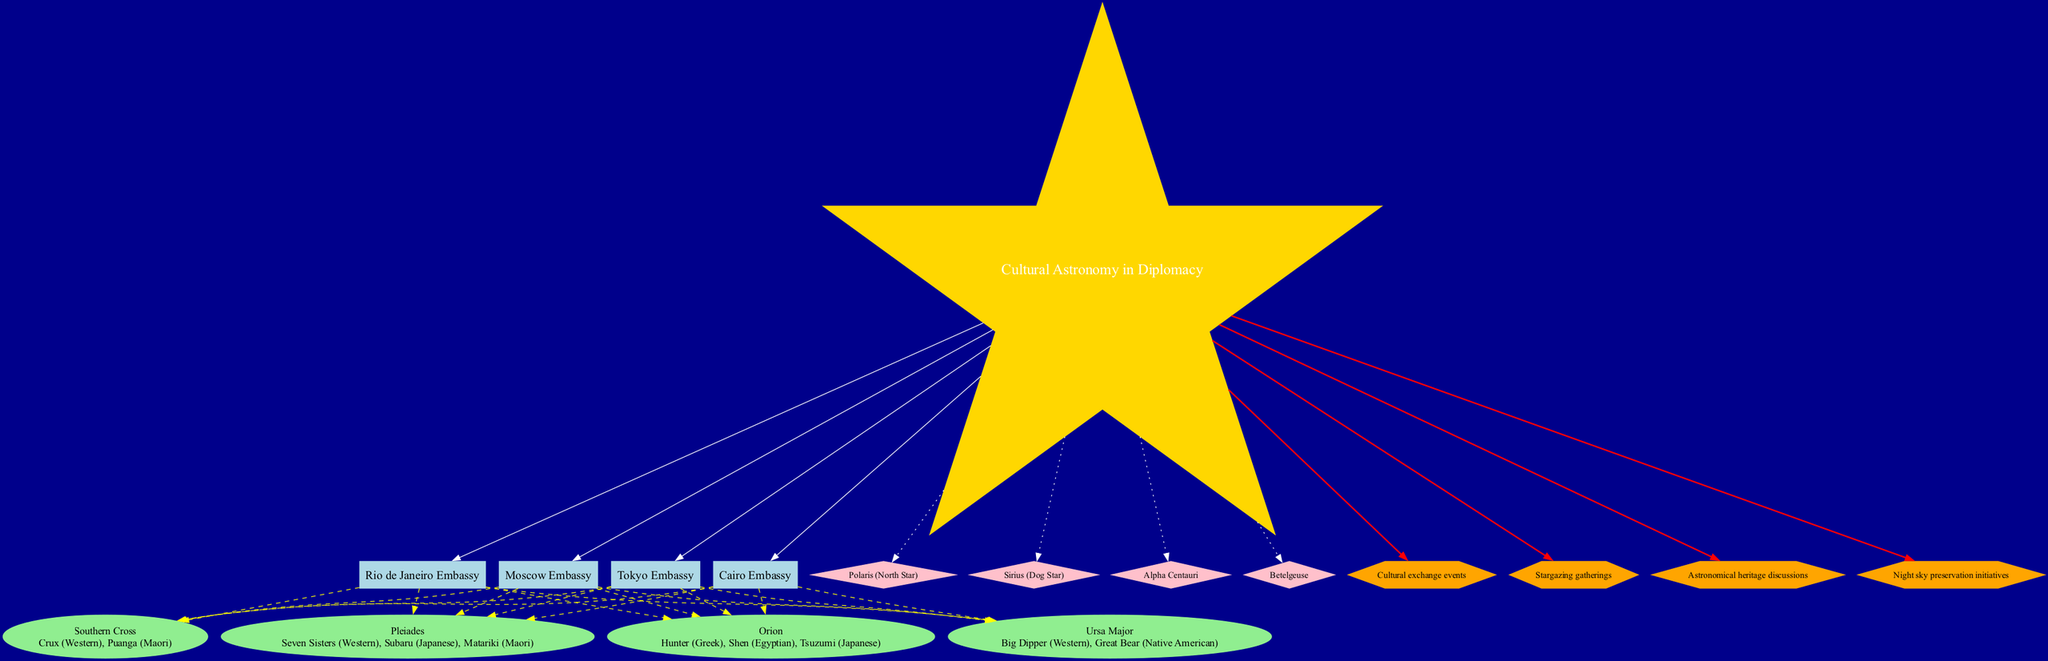What is the central node of the diagram? The central node is labeled "Cultural Astronomy in Diplomacy," which acts as the main topic connecting all other elements.
Answer: Cultural Astronomy in Diplomacy Which embassy location is connected to the constellation "Orion"? The diagram shows dashed edges from the "Tokyo Embassy," "Cairo Embassy," "Rio de Janeiro Embassy," and "Moscow Embassy" to the "Orion" node, indicating that all these embassy locations are related to the constellation.
Answer: Tokyo Embassy, Cairo Embassy, Rio de Janeiro Embassy, Moscow Embassy How many celestial objects are depicted in the diagram? The diagram lists four celestial objects, namely Polaris, Sirius, Alpha Centauri, and Betelgeuse. By counting these nodes, we can determine that the total is four.
Answer: 4 What cultural significance is associated with the constellation "Pleiades"? The "Pleiades" constellation is noted for its names such as "Seven Sisters" (Western), "Subaru" (Japanese), and "Matariki" (Maori), which can be found in the node detailing this constellation.
Answer: Seven Sisters, Subaru, Matariki Which diplomatic applications connect directly to the central node? Examining the edges from the central node shows it is connected to four specific diplomatic applications: "Cultural exchange events," "Stargazing gatherings," "Astronomical heritage discussions," and "Night sky preservation initiatives."
Answer: Cultural exchange events, Stargazing gatherings, Astronomical heritage discussions, Night sky preservation initiatives What type of shape is used for celestial object nodes? According to the styling of the diagram, celestial object nodes are represented with a diamond shape, which configures all celestial-related elements distinctly.
Answer: Diamond Which two constellations are linked to multiple cultural significances? The "Orion" and "Pleiades" constellations have multiple cultural significances noted in their respective nodes, showcasing their diverse interpretations across various cultures. These links reflect their rich cultural backgrounds in diplomacy.
Answer: Orion, Pleiades How many locations are represented in the diagram? The representation includes four specific embassy locations: "Tokyo Embassy," "Cairo Embassy," "Rio de Janeiro Embassy," and "Moscow Embassy," which can be directly counted from the location nodes.
Answer: 4 